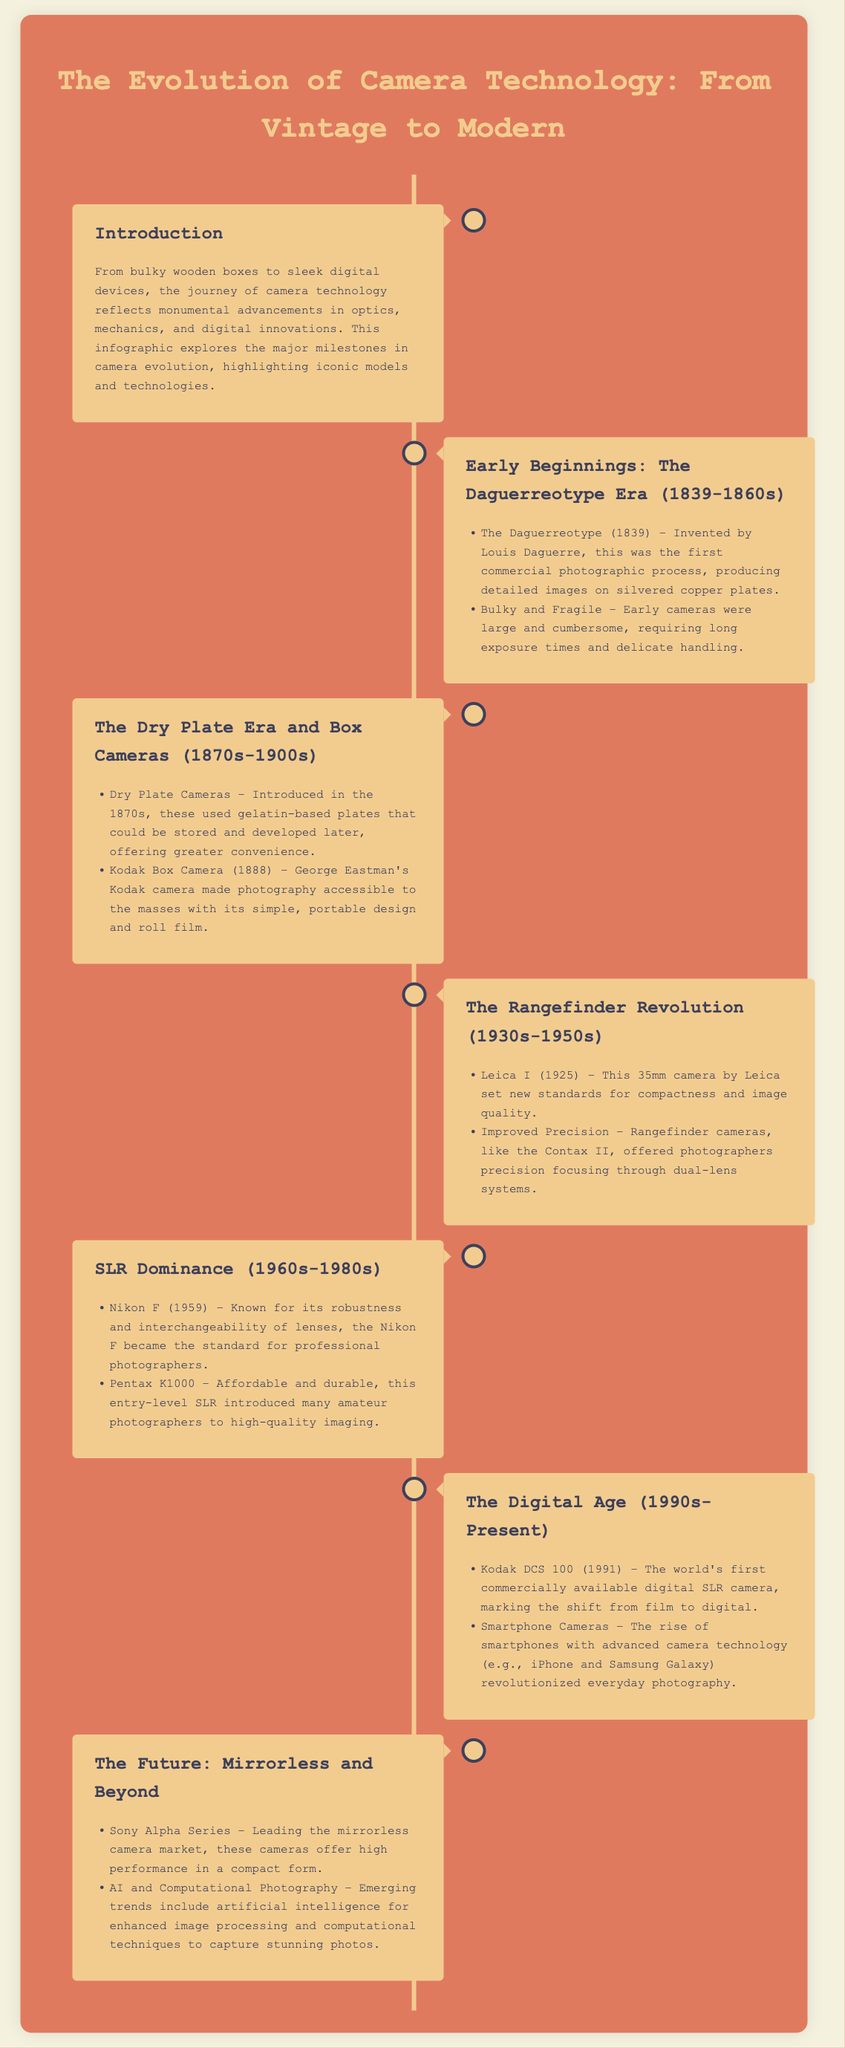What is the first commercial photographic process mentioned? The document states that the first commercial photographic process was the Daguerreotype, invented by Louis Daguerre.
Answer: Daguerreotype Which camera made photography accessible to the masses? The document highlights that the Kodak Box Camera, introduced by George Eastman, had a simple and portable design that made photography more accessible.
Answer: Kodak Box Camera What year was the Kodak DCS 100 released? The document notes that the Kodak DCS 100 was introduced in 1991 as the world's first commercially available digital SLR camera.
Answer: 1991 Who invented the Daguerreotype? According to the document, Louis Daguerre is credited with the invention of the Daguerreotype.
Answer: Louis Daguerre Which camera series leads the mirrorless market? The document specifies the Sony Alpha Series as leading the mirrorless camera market.
Answer: Sony Alpha Series What type of cameras did the Nikon F represent? The document describes the Nikon F as a standard for professional photographers, highlighting its robustness and lens interchangeability, which are features of SLR cameras.
Answer: SLR cameras What is a significant trend in the future of cameras mentioned? The document discusses artificial intelligence for enhanced image processing and computational techniques in photography as emerging trends.
Answer: AI and Computational Photography Which camera set new standards for compactness in 1925? The document indicates that the Leica I, introduced in 1925, set new standards for compactness and image quality.
Answer: Leica I 